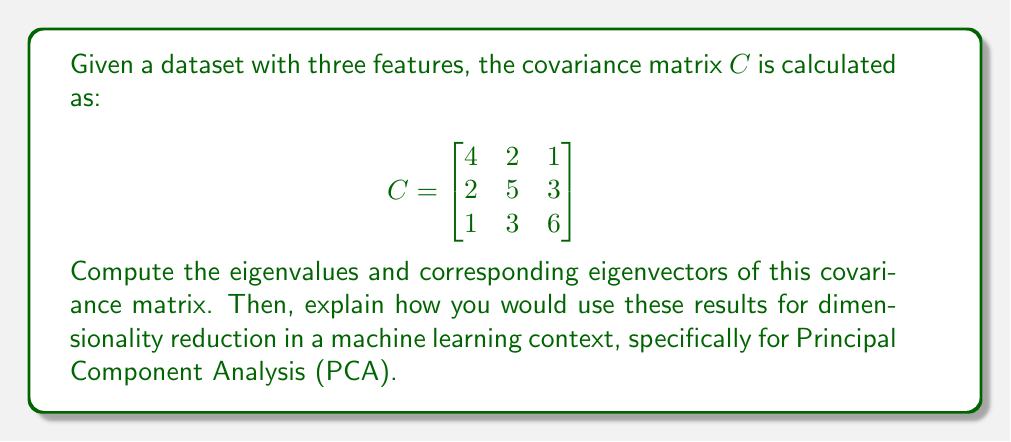Give your solution to this math problem. To find the eigenvalues and eigenvectors of the covariance matrix, we follow these steps:

1) First, we need to solve the characteristic equation:
   $det(C - \lambda I) = 0$

   Where $I$ is the 3x3 identity matrix and $\lambda$ represents the eigenvalues.

2) Expanding the determinant:

   $$det\begin{bmatrix}
   4-\lambda & 2 & 1 \\
   2 & 5-\lambda & 3 \\
   1 & 3 & 6-\lambda
   \end{bmatrix} = 0$$

3) This gives us the characteristic polynomial:
   $-\lambda^3 + 15\lambda^2 - 66\lambda + 80 = 0$

4) Solving this equation (you can use the cubic formula or numerical methods), we get the eigenvalues:
   $\lambda_1 \approx 8.90$
   $\lambda_2 \approx 4.76$
   $\lambda_3 \approx 1.34$

5) For each eigenvalue, we solve $(C - \lambda_i I)v_i = 0$ to find the corresponding eigenvector $v_i$.

6) After normalization, the eigenvectors are approximately:
   $v_1 \approx [0.34, 0.61, 0.71]^T$
   $v_2 \approx [-0.93, 0.30, 0.22]^T$
   $v_3 \approx [0.13, -0.73, 0.67]^T$

For dimensionality reduction using PCA:

1) The eigenvectors represent the principal components, with the first eigenvector (corresponding to the largest eigenvalue) being the first principal component, and so on.

2) The eigenvalues represent the amount of variance explained by each principal component.

3) To reduce dimensionality, we can project our data onto the first k eigenvectors, where k is less than the original number of dimensions. This preserves the maximum amount of variance in the reduced space.

4) The proportion of variance explained by each component is given by $\lambda_i / \sum \lambda_i$. In this case:
   Component 1: 59.3%
   Component 2: 31.7%
   Component 3: 8.9%

5) Depending on the desired level of dimensionality reduction, we could choose to keep only the first two principal components, which together explain about 91% of the variance in the data.
Answer: Eigenvalues: $\lambda_1 \approx 8.90$, $\lambda_2 \approx 4.76$, $\lambda_3 \approx 1.34$

Eigenvectors:
$v_1 \approx [0.34, 0.61, 0.71]^T$
$v_2 \approx [-0.93, 0.30, 0.22]^T$
$v_3 \approx [0.13, -0.73, 0.67]^T$

For dimensionality reduction, project the data onto the first two eigenvectors to preserve approximately 91% of the variance. 